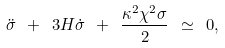Convert formula to latex. <formula><loc_0><loc_0><loc_500><loc_500>\ddot { \sigma } \ + \ 3 H \dot { \sigma } \ + \ \frac { \kappa ^ { 2 } \chi ^ { 2 } \sigma } { 2 } \ \simeq \ 0 ,</formula> 